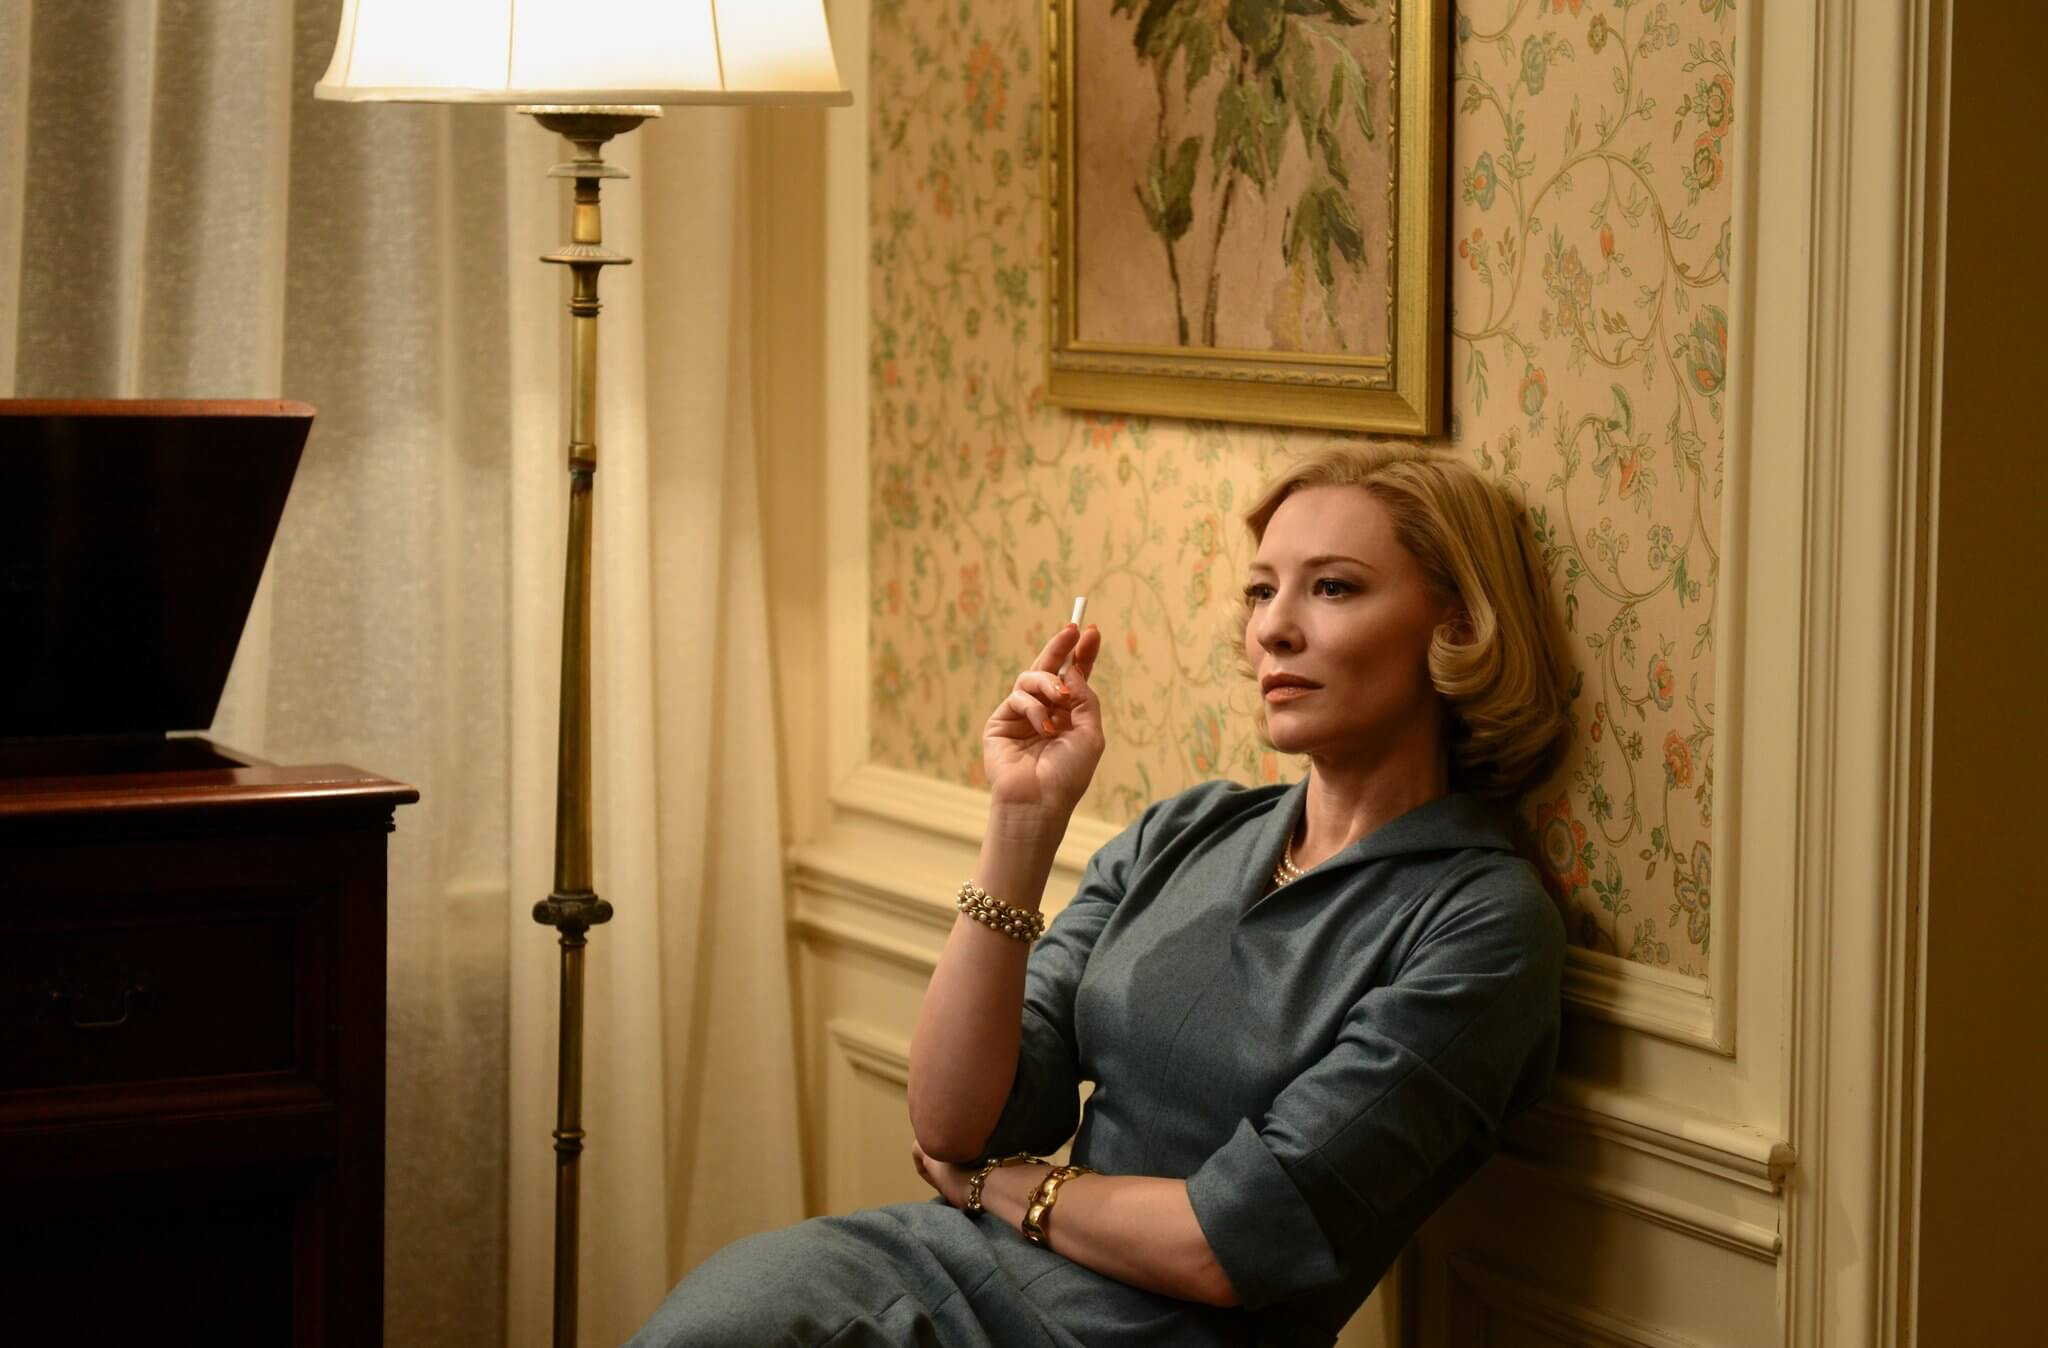Can you elaborate on the elements of the picture provided? In this image, an actress is captured in a poignant moment that conveys deep emotion. She is seated in a beige armchair, located within a room decorated with vintage floral wallpaper that evokes a nostalgic atmosphere. She wears a tailored blue outfit and holds a cigarette, which adds to the contemplative and somewhat melancholic mood of the scene. Her eyes are directed off to the side, her expression thoughtful and pensive, as if lost in a deep, unresolved thought. A lamp casts a warm glow over her figure, and a wooden desk is partially visible in the background. On the wall, a framed painting of leaves further enhances the vintage aesthetic, creating a rich, immersive setting that invites viewers to explore the nuances and underlying narratives of the scene. 